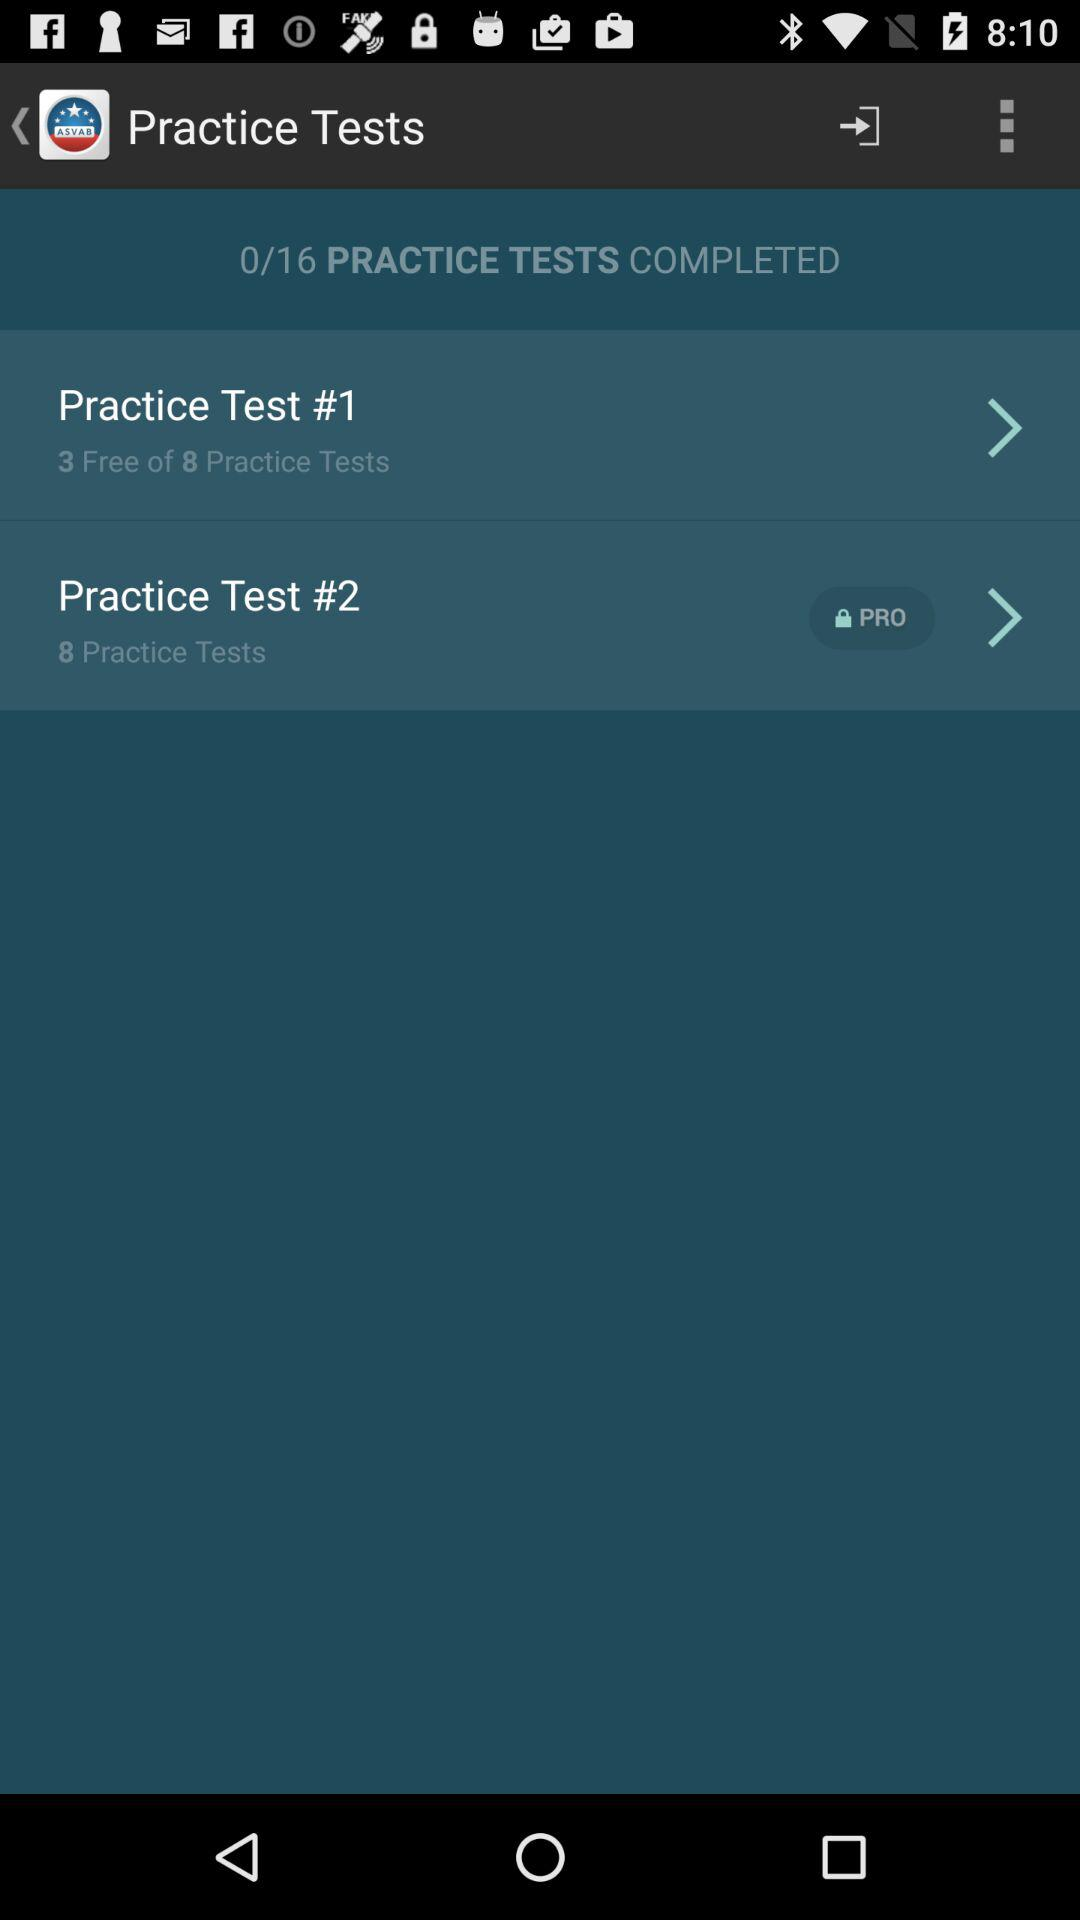What is the total number of tests in "Practice Test #1"? There are 8 tests. 